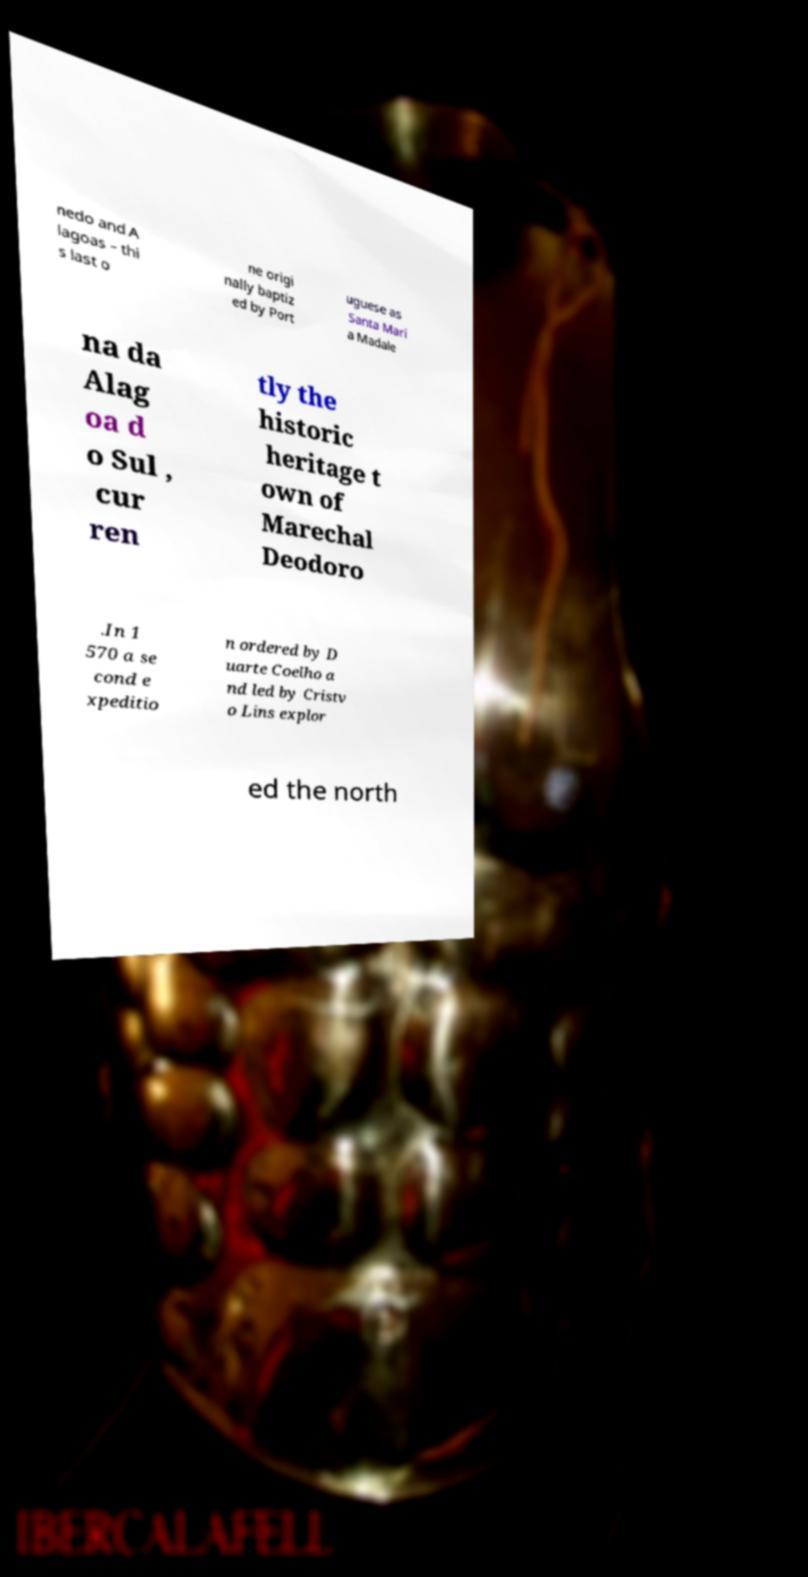Can you accurately transcribe the text from the provided image for me? nedo and A lagoas – thi s last o ne origi nally baptiz ed by Port uguese as Santa Mari a Madale na da Alag oa d o Sul , cur ren tly the historic heritage t own of Marechal Deodoro .In 1 570 a se cond e xpeditio n ordered by D uarte Coelho a nd led by Cristv o Lins explor ed the north 